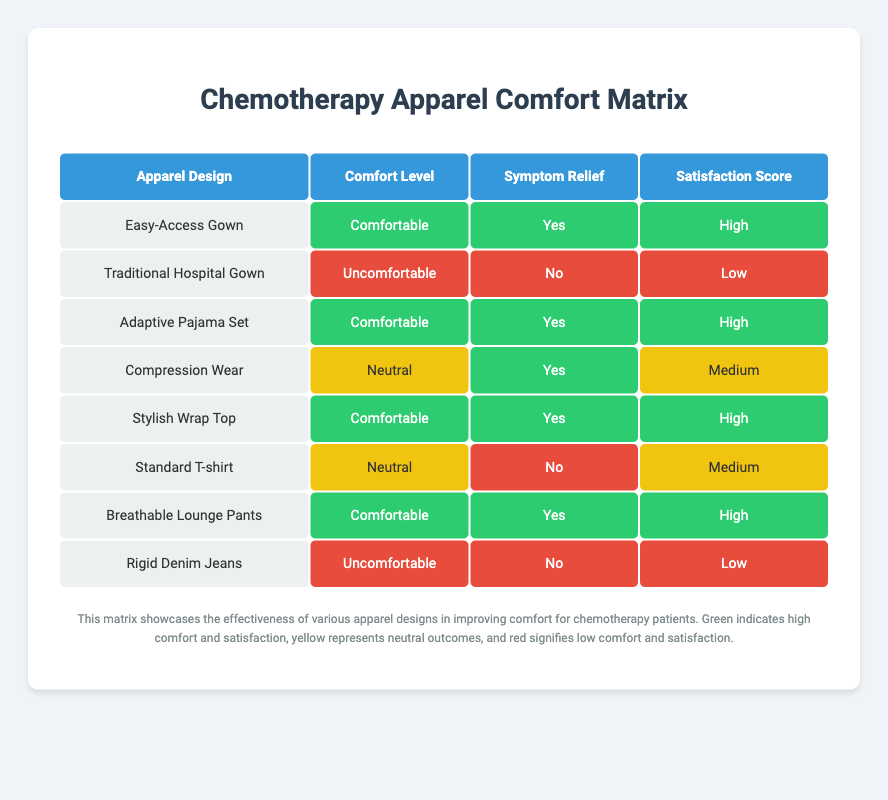What is the comfort level of the Easy-Access Gown? The table shows that the Easy-Access Gown has a comfort level categorized as "Comfortable."
Answer: Comfortable How many apparel designs offer symptom relief? By scanning the Symptom Relief column, we see "Yes" appears for the Easy-Access Gown, Adaptive Pajama Set, Compression Wear, Stylish Wrap Top, and Breathable Lounge Pants. This gives us a total of 5 designs that offer symptom relief.
Answer: 5 Is the satisfaction score for Rigid Denim Jeans high? The table indicates that the satisfaction score for Rigid Denim Jeans is classified as "Low," hence it is not high.
Answer: No What is the average satisfaction score (using a 3-tier system: High=3, Medium=2, Low=1) among all apparel designs? Assigning numeric values, we find High = 3 for 5 designs, Medium = 2 for 3 designs, and Low = 1 for 2 designs. The total score is (3*5 + 2*3 + 1*2) = 22, and there are 8 designs. The average satisfaction score is 22/8 = 2.75, which translates to approximately 2.75, or between Medium and High.
Answer: 2.75 Which apparel design had the lowest comfort level and what is its satisfaction score? Scanning the Comfort Level column, Rigid Denim Jeans is marked as "Uncomfortable," and in the satisfaction score column, it is also rated "Low."
Answer: Rigid Denim Jeans, Low 